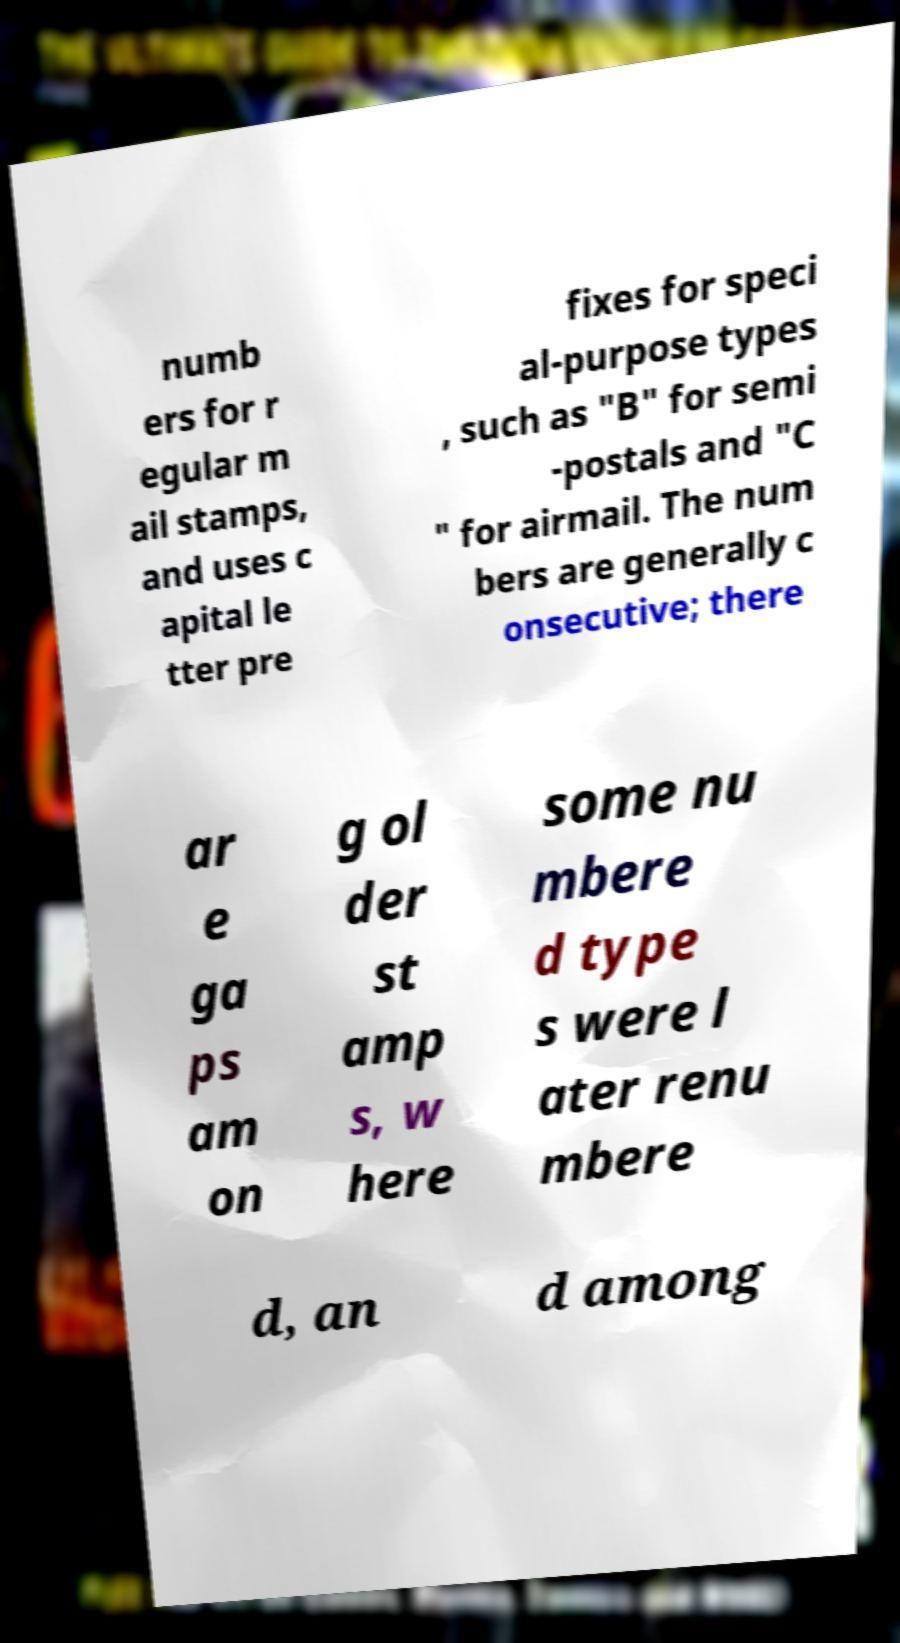For documentation purposes, I need the text within this image transcribed. Could you provide that? numb ers for r egular m ail stamps, and uses c apital le tter pre fixes for speci al-purpose types , such as "B" for semi -postals and "C " for airmail. The num bers are generally c onsecutive; there ar e ga ps am on g ol der st amp s, w here some nu mbere d type s were l ater renu mbere d, an d among 